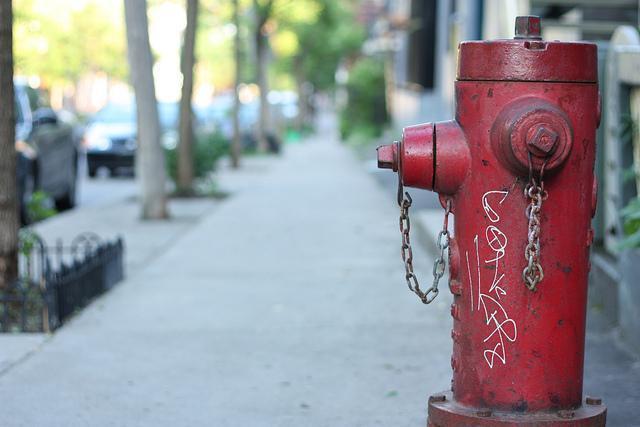Why are there chains on the red thing?
Choose the right answer from the provided options to respond to the question.
Options: Prevent break-in, hold lids, purely aesthetic, provides strength. Hold lids. 